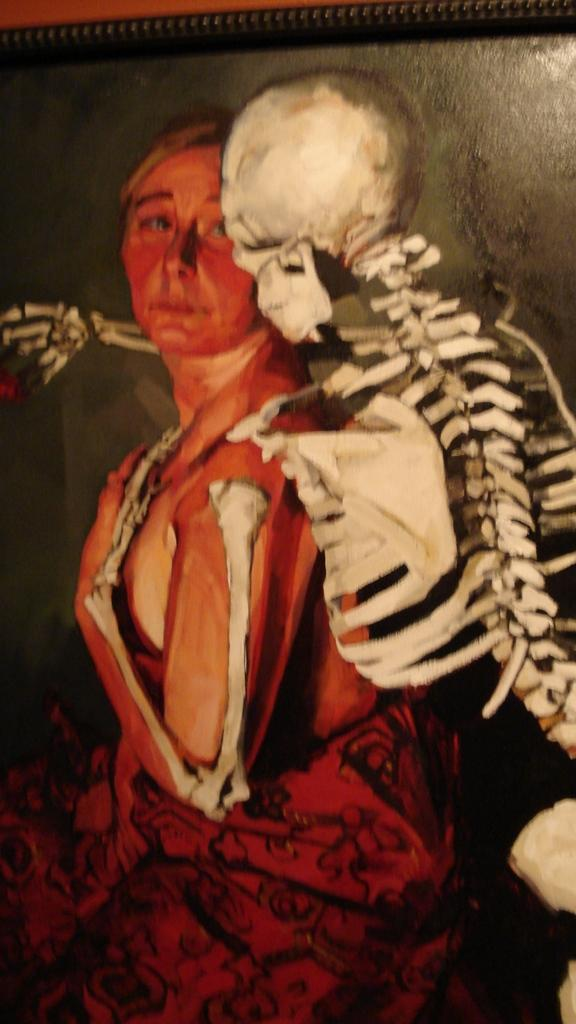What is the main subject of the image? The main subject of the image is a photo frame. Who or what is depicted inside the photo frame? There is a woman and a skeleton inside the photo frame. What is the color of the background in the photo frame? The background of the photo frame is black in color. What is the color of the top part of the photo frame? The top part of the photo frame is orange in color. What type of silverware is used as an example in the photo frame? There is no silverware or example present in the photo frame; it contains a woman and a skeleton. What is the journey like for the woman and the skeleton in the photo frame? The image is a still photo, so there is no journey or movement depicted for the woman and the skeleton. 